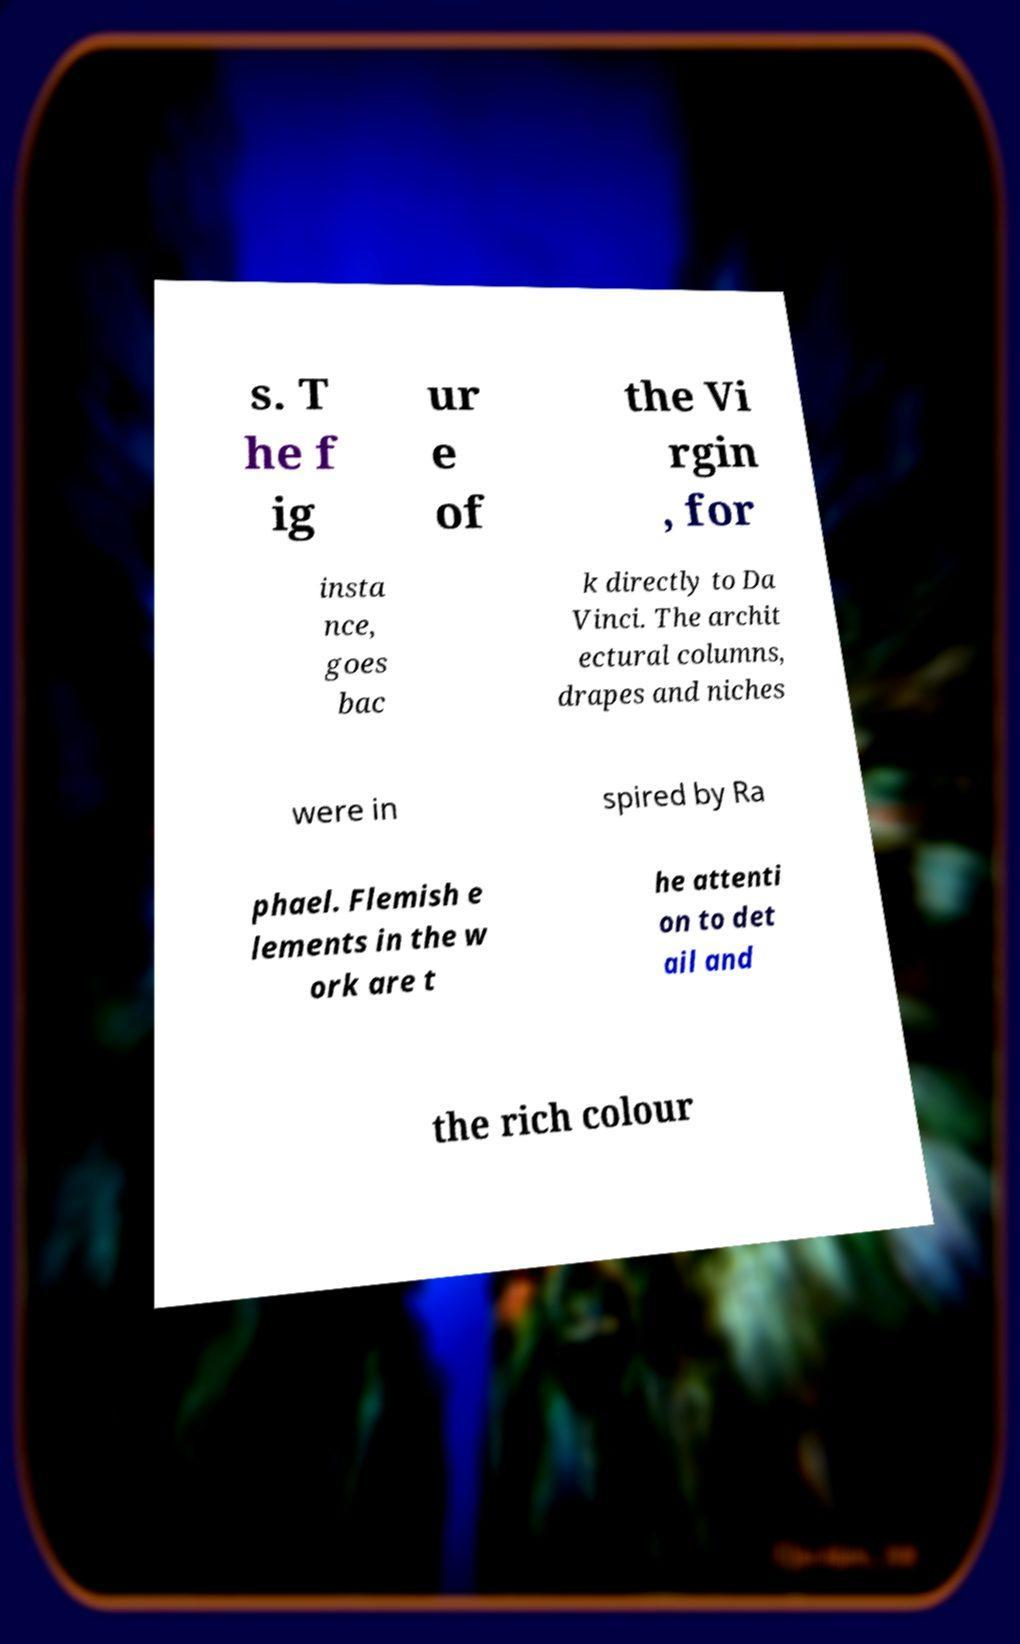Please read and relay the text visible in this image. What does it say? s. T he f ig ur e of the Vi rgin , for insta nce, goes bac k directly to Da Vinci. The archit ectural columns, drapes and niches were in spired by Ra phael. Flemish e lements in the w ork are t he attenti on to det ail and the rich colour 